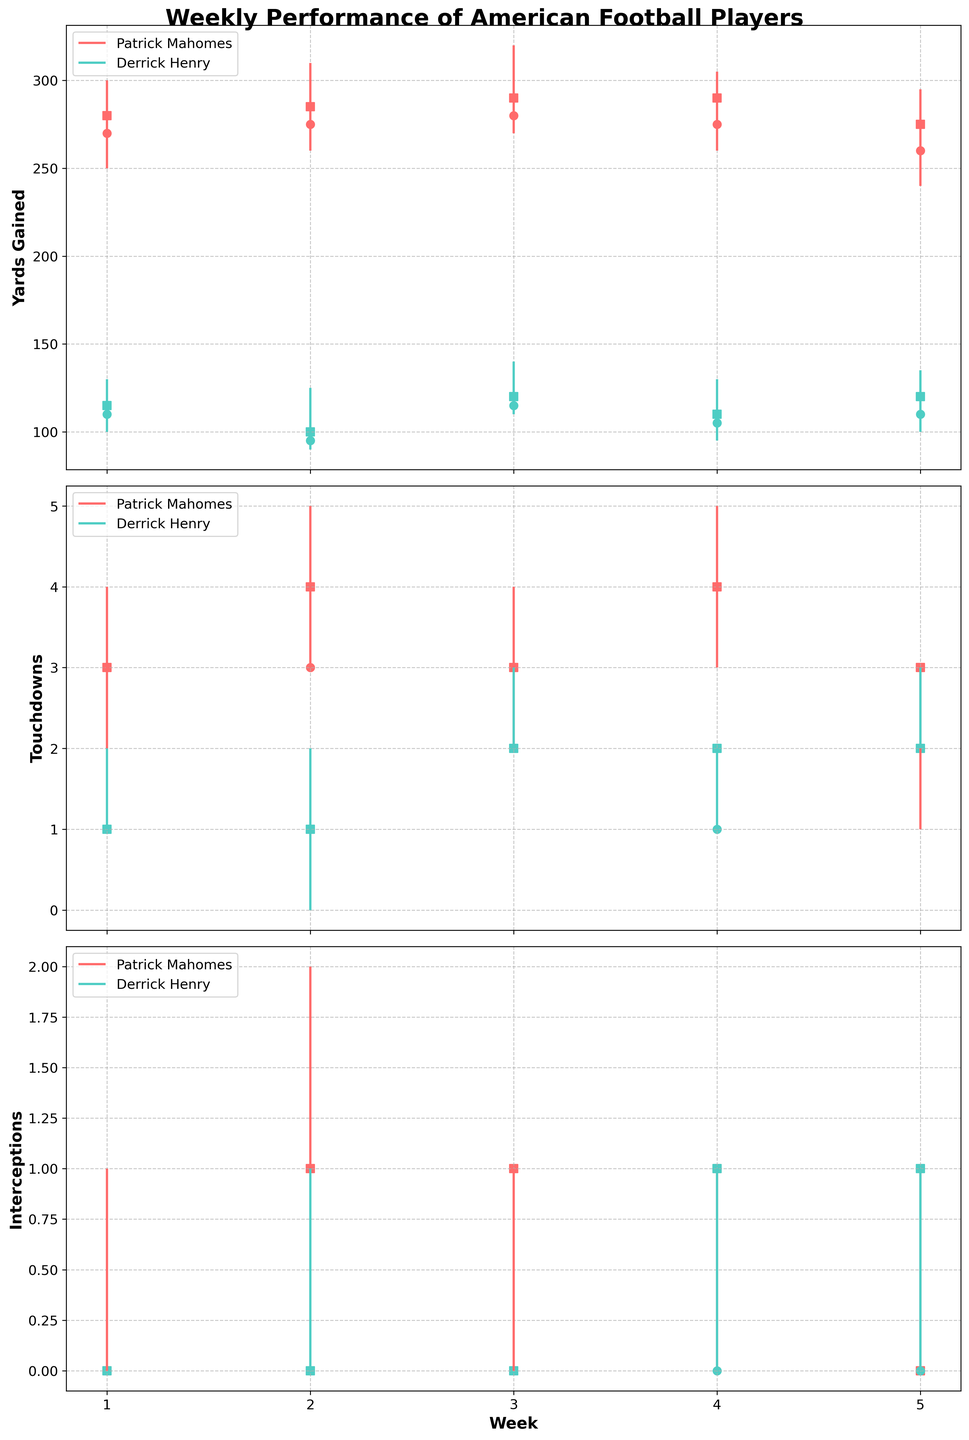What are the high and low yard marks for Patrick Mahomes in Week 2? In Week 2, the high mark for Patrick Mahomes is the maximum value captured by the vertical line at the corresponding week, and the low mark is the minimum value. For Patrick Mahomes, the high yard mark in Week 2 is 310 yards, and the low yard mark is 260 yards.
Answer: 310 yards, 260 yards During which week did Derrick Henry achieve his highest number of touchdowns, and what was that number? Looking at Derrick Henry's vertical lines in the Touchdowns plot, the week with the highest high mark is Week 3, where he achieved 3 touchdowns.
Answer: Week 3, 3 touchdowns Did Patrick Mahomes have any touchdowns in Week 5, and if so, how many did he start and end with? Check the Touchdowns plot for Week 5 and Patrick Mahomes. The chart shows circles and squares to represent the open and close values. In Week 5, Patrick Mahomes started with 2 touchdowns (circle) and ended with 3 touchdowns (square).
Answer: Yes, 2 touchdowns (start), 3 touchdowns (end) What week did Derrick Henry have the most interceptions, and how many were there? In the Interceptions plot, find the week where Derrick Henry's high mark is at its peak. That peak occurs in Weeks 4 and 5, both with 1 interception.
Answer: Weeks 4 and 5, 1 interception Compare Patrick Mahomes' yards gained in Week 1 and Week 3. In Week 1, Patrick Mahomes has a range from 250 to 300 yards gained. In Week 3, his range is from 270 to 320 yards. By comparing these ranges, Week 3 shows higher gained yards both in its minimum and maximum bounds.
Answer: Week 3 has higher yards gained Which player shows more consistency in touchdowns over the observed weeks, and how can you tell? Consistency can be determined by looking at how spread out or tight the vertical lines are in the Touchdowns plot. Patrick Mahomes shows less variability with frequently closer high and low marks compared to Derrick Henry, indicating more consistent touchdowns.
Answer: Patrick Mahomes What is the average closing yards for Derrick Henry over the 5 weeks? Add the closing yards for Derrick Henry over the 5 weeks: 115, 100, 120, 110, 120. Then divide by 5. The sum is 565 yards, so the average is 565 / 5 = 113 yards.
Answer: 113 yards Which player had the most interceptions in Week 2? In the Week 2 section of the Interceptions plot, compare the high marks of both players. Patrick Mahomes had a high of 2 interceptions, while Derrick Henry had a high of 1 interception. Thus, Patrick Mahomes had more interceptions.
Answer: Patrick Mahomes What was the highest number of yards gained by any player in any week, and on which week did it occur? Check all high marks for both players in the Yards Gained plot. The highest mark is 320 yards gained by Patrick Mahomes in Week 3.
Answer: 320 yards, Week 3 In Week 4, during which player saw an increase in touchdowns from open to close, and what's the difference? In Week 4 on the Touchdowns plot, look at the circle and square for each player to determine an increase from open to close. Derrick Henry shows an increase from 1 to 2 touchdowns, a difference of 1.
Answer: Derrick Henry, 1 touchdown 